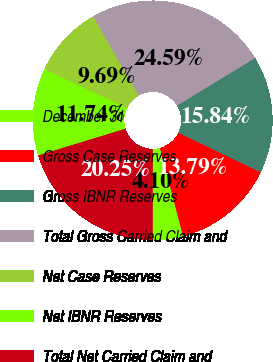Convert chart. <chart><loc_0><loc_0><loc_500><loc_500><pie_chart><fcel>December 31<fcel>Gross Case Reserves<fcel>Gross IBNR Reserves<fcel>Total Gross Carried Claim and<fcel>Net Case Reserves<fcel>Net IBNR Reserves<fcel>Total Net Carried Claim and<nl><fcel>4.1%<fcel>13.79%<fcel>15.84%<fcel>24.59%<fcel>9.69%<fcel>11.74%<fcel>20.25%<nl></chart> 